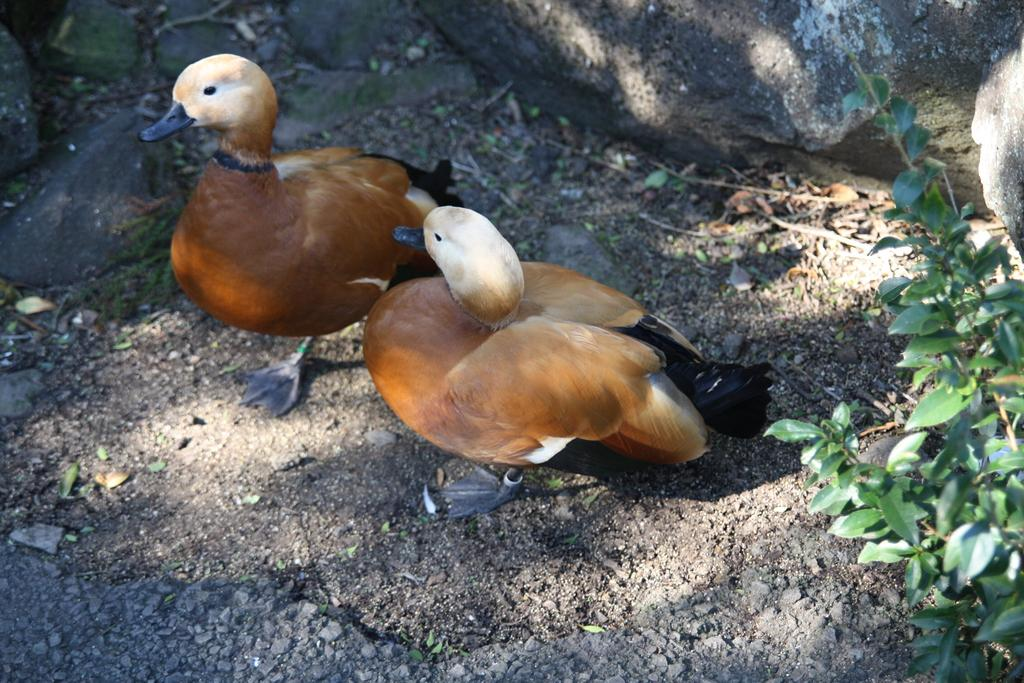How many birds are in the image? There are two birds in the image. What type of birds do they resemble? The birds resemble ducks. Where are the birds located in the image? The birds are on the ground. What colors can be seen on the birds? The birds have brown and cream coloring. What else can be seen in the image besides the birds? There is a plant on the right side of the image. What type of glass is being used by the slave in the image? There is no glass or slave present in the image; it features two birds and a plant. 